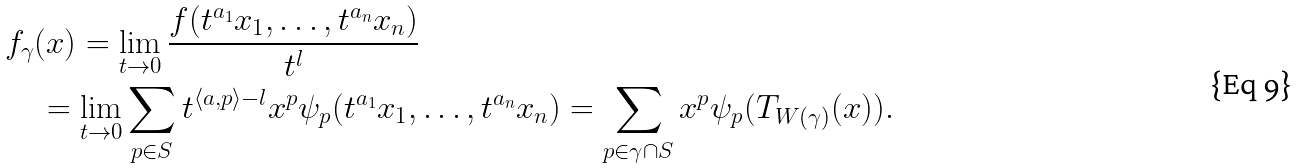<formula> <loc_0><loc_0><loc_500><loc_500>& f _ { \gamma } ( x ) = \lim _ { t \to 0 } \frac { f ( t ^ { a _ { 1 } } x _ { 1 } , \dots , t ^ { a _ { n } } x _ { n } ) } { t ^ { l } } \\ & \quad = \lim _ { t \to 0 } \sum _ { p \in S } t ^ { \langle a , p \rangle - l } x ^ { p } \psi _ { p } ( t ^ { a _ { 1 } } x _ { 1 } , \dots , t ^ { a _ { n } } x _ { n } ) = \sum _ { p \in \gamma \cap S } x ^ { p } \psi _ { p } ( T _ { W ( \gamma ) } ( x ) ) .</formula> 